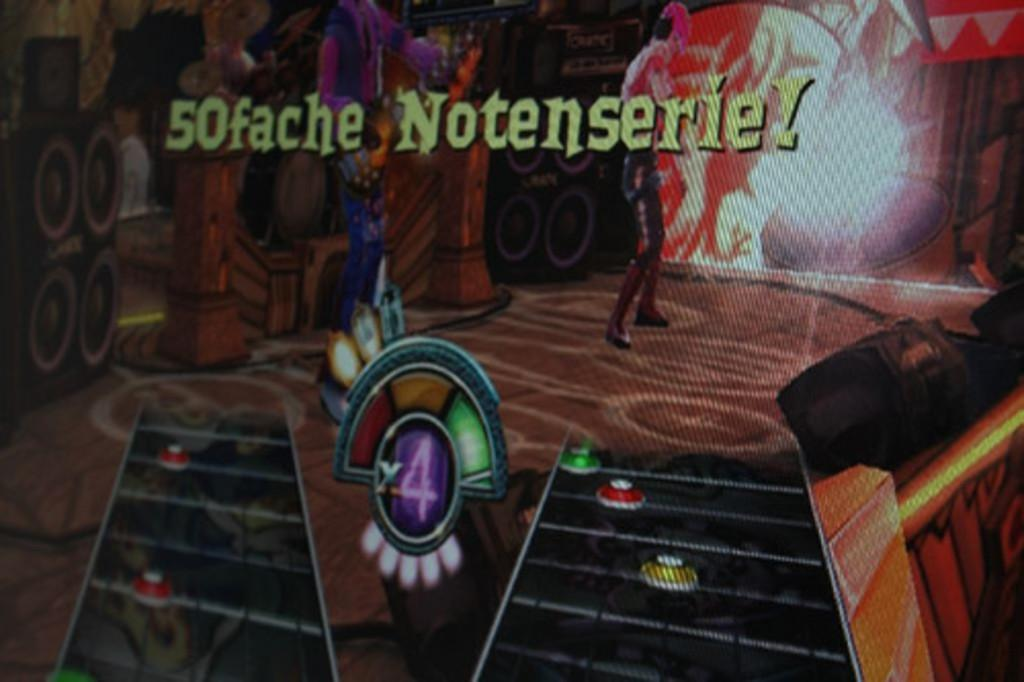What is the main object in the image? There is a screen in the image. What is displayed on the screen? The screen displays an animated image of a man. Where is the animated man located in the image? The animated image of the man is on a floor. What else can be seen in the animated image? Other objects are visible in the animated image. How does the steam affect the calculator in the image? There is no calculator or steam present in the image. 